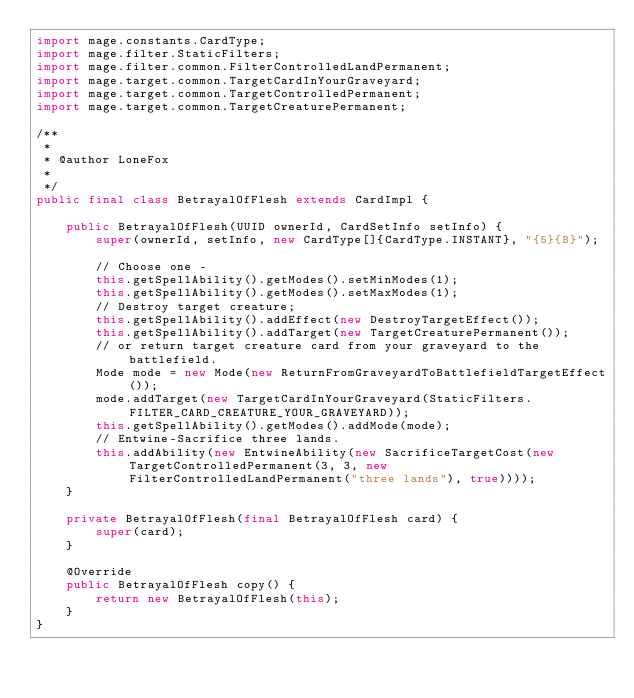<code> <loc_0><loc_0><loc_500><loc_500><_Java_>import mage.constants.CardType;
import mage.filter.StaticFilters;
import mage.filter.common.FilterControlledLandPermanent;
import mage.target.common.TargetCardInYourGraveyard;
import mage.target.common.TargetControlledPermanent;
import mage.target.common.TargetCreaturePermanent;

/**
 *
 * @author LoneFox
 *
 */
public final class BetrayalOfFlesh extends CardImpl {

    public BetrayalOfFlesh(UUID ownerId, CardSetInfo setInfo) {
        super(ownerId, setInfo, new CardType[]{CardType.INSTANT}, "{5}{B}");

        // Choose one -
        this.getSpellAbility().getModes().setMinModes(1);
        this.getSpellAbility().getModes().setMaxModes(1);
        // Destroy target creature;
        this.getSpellAbility().addEffect(new DestroyTargetEffect());
        this.getSpellAbility().addTarget(new TargetCreaturePermanent());
        // or return target creature card from your graveyard to the battlefield.
        Mode mode = new Mode(new ReturnFromGraveyardToBattlefieldTargetEffect());
        mode.addTarget(new TargetCardInYourGraveyard(StaticFilters.FILTER_CARD_CREATURE_YOUR_GRAVEYARD));
        this.getSpellAbility().getModes().addMode(mode);
        // Entwine-Sacrifice three lands.
        this.addAbility(new EntwineAbility(new SacrificeTargetCost(new TargetControlledPermanent(3, 3, new FilterControlledLandPermanent("three lands"), true))));
    }

    private BetrayalOfFlesh(final BetrayalOfFlesh card) {
        super(card);
    }

    @Override
    public BetrayalOfFlesh copy() {
        return new BetrayalOfFlesh(this);
    }
}
</code> 